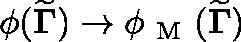<formula> <loc_0><loc_0><loc_500><loc_500>\phi ( { \widetilde { \Gamma } } ) \to \phi _ { M } ( { \widetilde { \Gamma } } )</formula> 